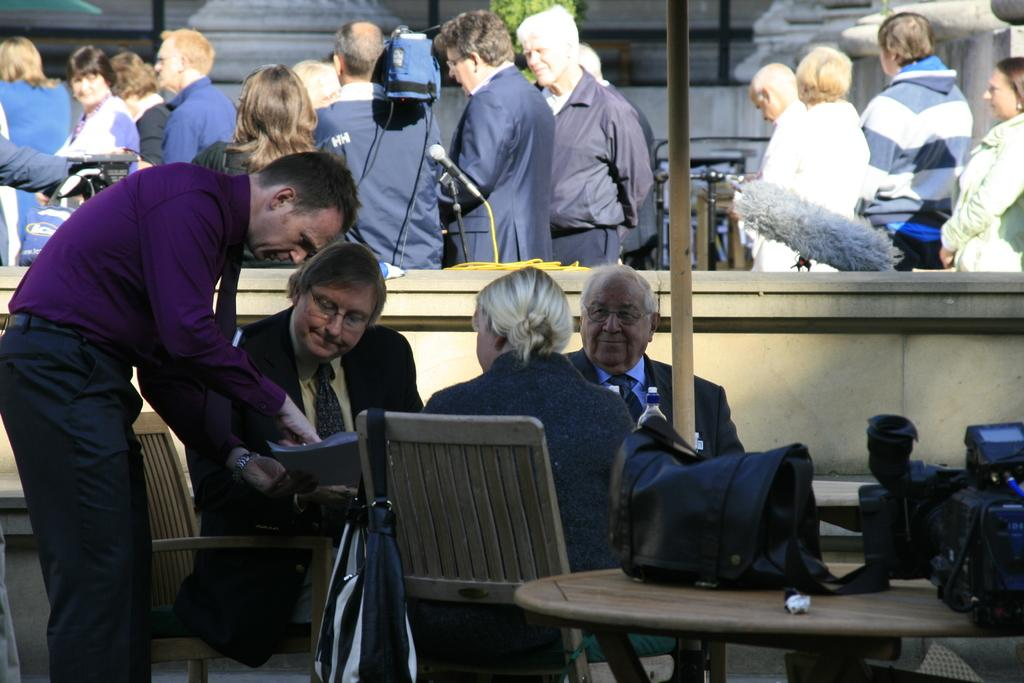What is the main activity taking place in the image? People are sitting around a table, which suggests a meeting or discussion. Can you describe the setting of the image? The setting appears to be in a conference hall, as indicated by the presence of chairs and tables. What is happening in the background of the image? There are many people standing in the background, which might indicate that the event is well-attended. What type of popcorn is being sold at the market in the image? There is no market or popcorn present in the image; it depicts a conference hall setting with people sitting around a table. 